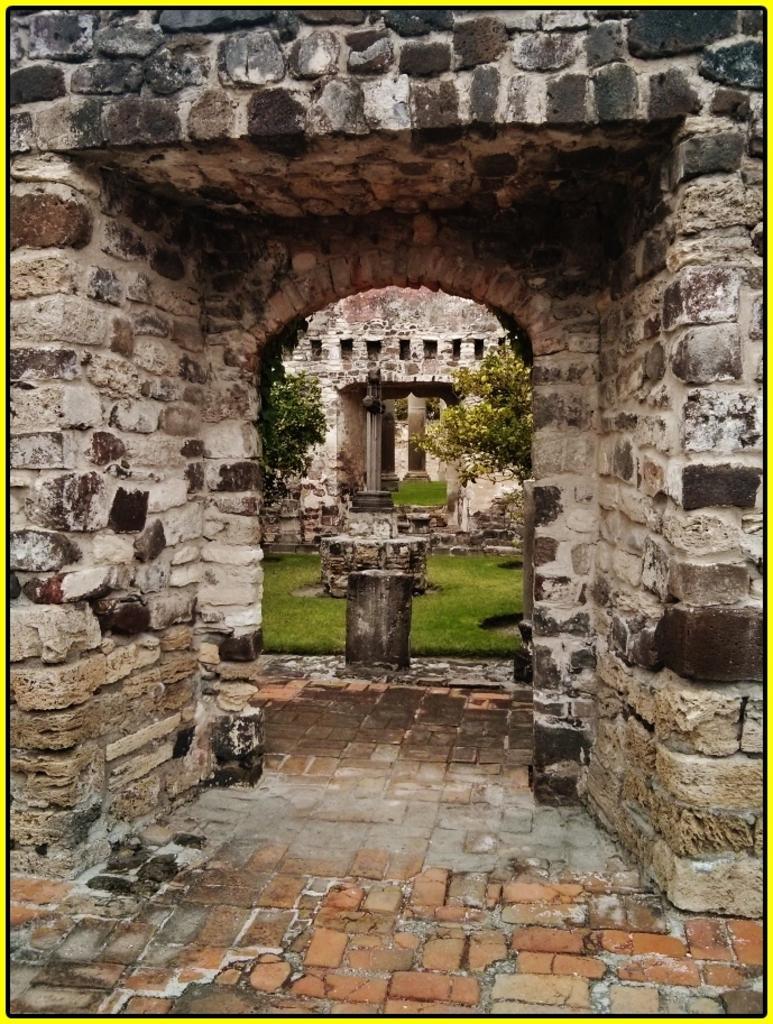How would you summarize this image in a sentence or two? This is grass and there is a wall. Here we can see trees and pillars. 